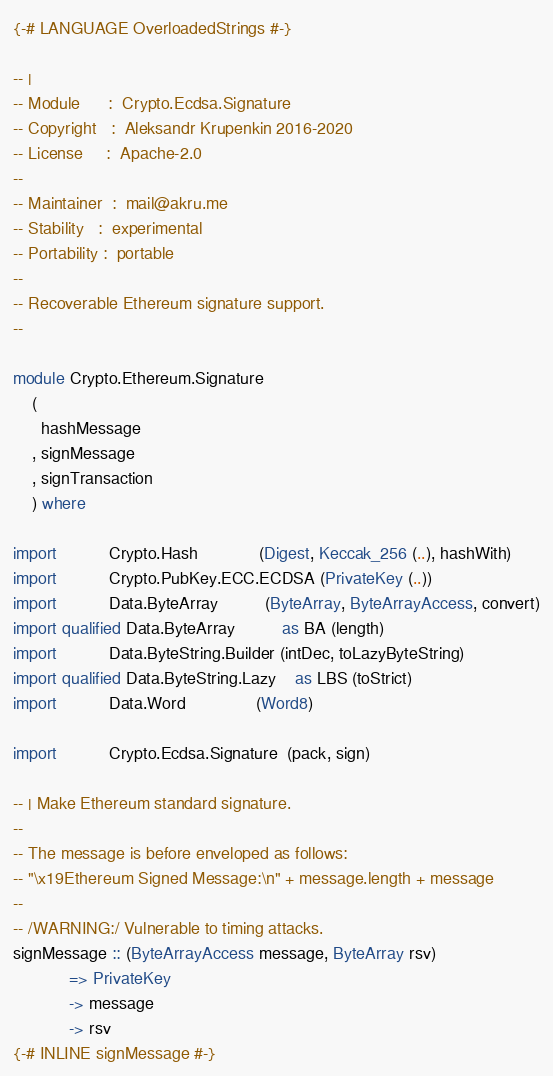<code> <loc_0><loc_0><loc_500><loc_500><_Haskell_>{-# LANGUAGE OverloadedStrings #-}

-- |
-- Module      :  Crypto.Ecdsa.Signature
-- Copyright   :  Aleksandr Krupenkin 2016-2020
-- License     :  Apache-2.0
--
-- Maintainer  :  mail@akru.me
-- Stability   :  experimental
-- Portability :  portable
--
-- Recoverable Ethereum signature support.
--

module Crypto.Ethereum.Signature
    (
      hashMessage
    , signMessage
    , signTransaction
    ) where

import           Crypto.Hash             (Digest, Keccak_256 (..), hashWith)
import           Crypto.PubKey.ECC.ECDSA (PrivateKey (..))
import           Data.ByteArray          (ByteArray, ByteArrayAccess, convert)
import qualified Data.ByteArray          as BA (length)
import           Data.ByteString.Builder (intDec, toLazyByteString)
import qualified Data.ByteString.Lazy    as LBS (toStrict)
import           Data.Word               (Word8)

import           Crypto.Ecdsa.Signature  (pack, sign)

-- | Make Ethereum standard signature.
--
-- The message is before enveloped as follows:
-- "\x19Ethereum Signed Message:\n" + message.length + message
--
-- /WARNING:/ Vulnerable to timing attacks.
signMessage :: (ByteArrayAccess message, ByteArray rsv)
            => PrivateKey
            -> message
            -> rsv
{-# INLINE signMessage #-}</code> 